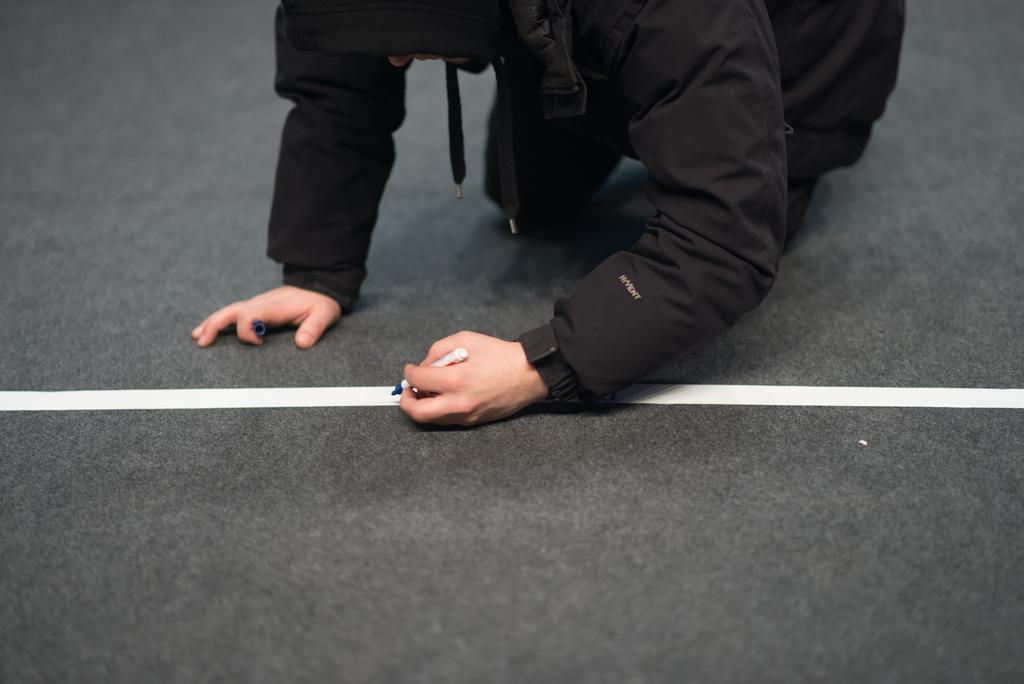What is the color of the ground in the image? The ground in the image is black in color. What is present on the black ground? There is a white colored line on the ground. Can you describe the person in the image? The person in the image is wearing a black color dress. What is the person holding in his hand? The person is holding a pen in his hand. How many brothers does the person in the image have? There is no information about the person's brothers in the image. Is the person in the image walking or rolling? The image does not show the person walking or rolling; it only shows them standing and holding a pen. 